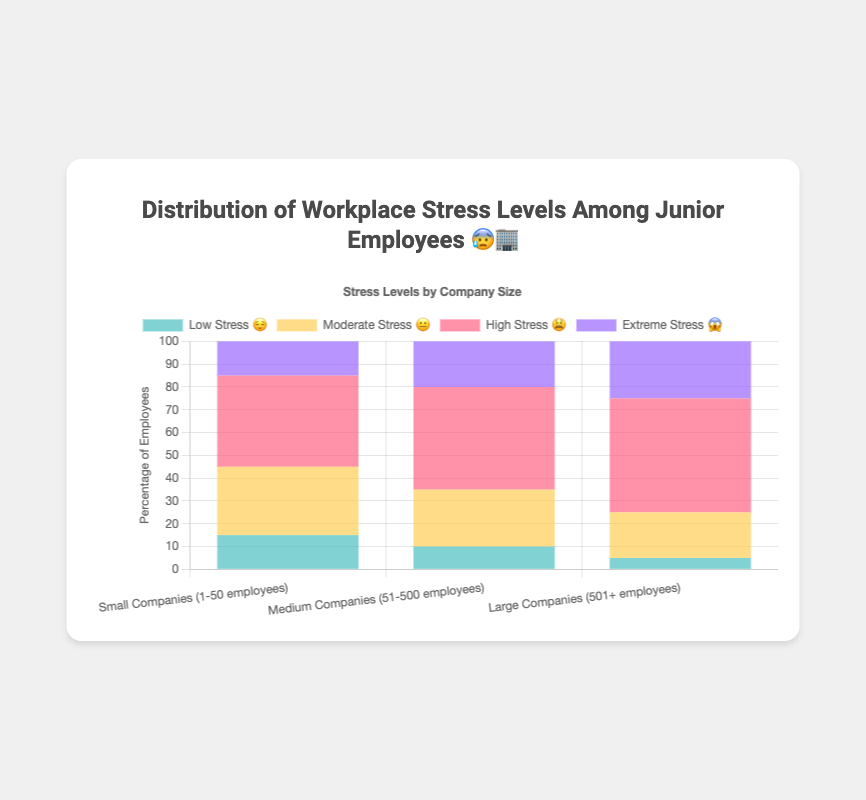Which company size has the highest percentage of low-stress junior employees? In the figure, the percentage of low-stress junior employees is highest in small companies (1-50 employees) with 15%.
Answer: Small Companies (1-50 employees) What percentage of junior employees experience high stress in medium-sized companies? From the figure, we observe that medium-sized companies (51-500 employees) have 45% of junior employees experiencing high stress.
Answer: 45% How does the percentage of extreme stress in large companies compare to small companies? Looking at the figure, large companies (501+ employees) have 25% extreme stress, whereas small companies (1-50 employees) have 15%. So, large companies have a higher percentage of extreme stress by 10%.
Answer: 10% higher Which stress level is most common among junior employees in large companies? The figure indicates that in large companies (501+ employees), the most common stress level among junior employees is high stress at 50%.
Answer: High Stress What is the total percentage of junior employees experiencing moderate stress across all company sizes? To find the total percentage, add the percentages of moderate stress for each company size: 30% (small) + 25% (medium) + 20% (large) = 75%.
Answer: 75% In small companies, how does the percentage of moderate stress compare to extreme stress? The figure shows that moderate stress in small companies (1-50 employees) is 30%, while extreme stress is 15%. This means moderate stress is 15% higher than extreme stress.
Answer: 15% higher What is the difference between the highest and lowest stress level percentages in medium-sized companies? For medium-sized companies (51-500 employees), the highest stress level is high stress at 45% and the lowest is low stress at 10%. The difference is 45% - 10% = 35%.
Answer: 35% Across all company sizes, which stress level is reported the least? Based on the figure, low stress is reported the least across all company sizes with percentages of 15% (small), 10% (medium), and 5% (large). The lowest among these is in large companies at 5%.
Answer: Low Stress Which company size shows the highest percentage of extreme stress among junior employees? The figure shows that large companies (501+ employees) have the highest percentage of extreme stress among junior employees at 25%.
Answer: Large Companies (501+ employees) If you sum the percentages of extreme stress and high stress in small companies, what do you get? In small companies (1-50 employees), the percentage of extreme stress is 15% and high stress is 40%. Adding these together, we get 15% + 40% = 55%.
Answer: 55% 